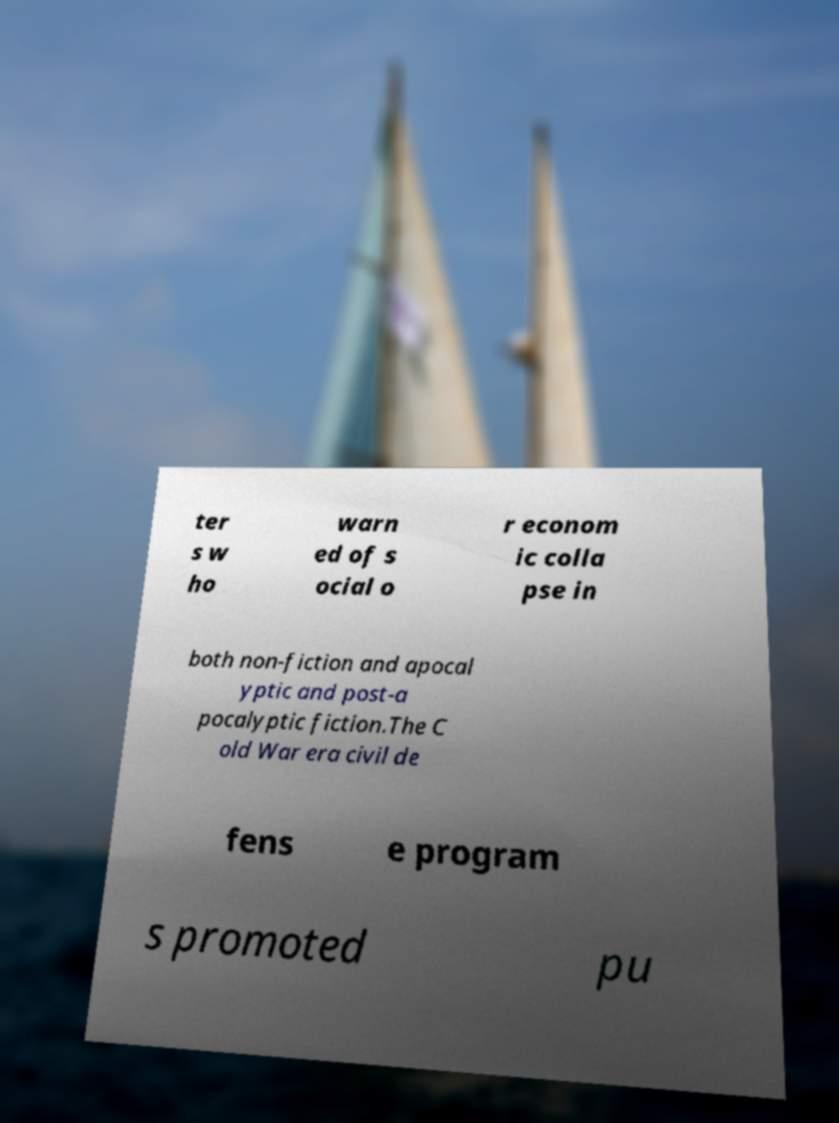I need the written content from this picture converted into text. Can you do that? ter s w ho warn ed of s ocial o r econom ic colla pse in both non-fiction and apocal yptic and post-a pocalyptic fiction.The C old War era civil de fens e program s promoted pu 